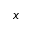Convert formula to latex. <formula><loc_0><loc_0><loc_500><loc_500>x</formula> 